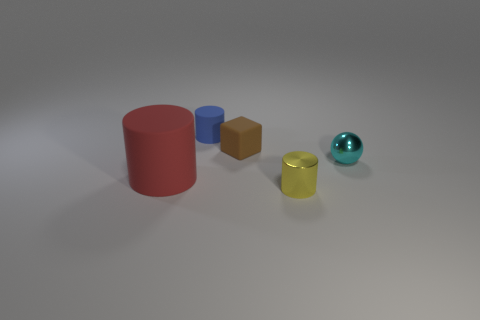What is the material of the cylinder that is in front of the small rubber block and behind the yellow cylinder?
Provide a succinct answer. Rubber. Does the cylinder behind the cyan metallic object have the same size as the small cyan shiny thing?
Provide a short and direct response. Yes. There is a large object; what shape is it?
Offer a terse response. Cylinder. What number of tiny things are the same shape as the big red matte object?
Give a very brief answer. 2. What number of small things are right of the blue rubber cylinder and behind the small yellow object?
Offer a very short reply. 2. The metallic cylinder is what color?
Keep it short and to the point. Yellow. Are there any blue things that have the same material as the tiny ball?
Your answer should be compact. No. There is a thing that is on the left side of the matte cylinder that is behind the red cylinder; is there a cylinder behind it?
Ensure brevity in your answer.  Yes. There is a blue rubber cylinder; are there any blue matte things behind it?
Ensure brevity in your answer.  No. What number of big objects are red objects or cubes?
Give a very brief answer. 1. 